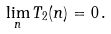<formula> <loc_0><loc_0><loc_500><loc_500>\lim _ { n } T _ { 2 } ( n ) = 0 \, .</formula> 